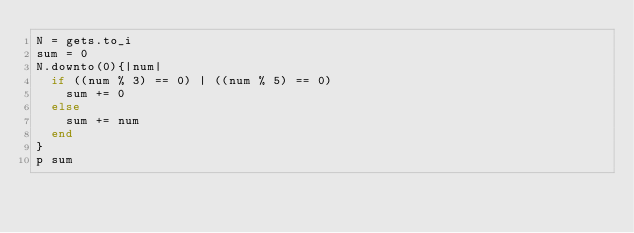Convert code to text. <code><loc_0><loc_0><loc_500><loc_500><_Ruby_>N = gets.to_i
sum = 0
N.downto(0){|num|
  if ((num % 3) == 0) | ((num % 5) == 0)
    sum += 0
  else
  	sum += num
  end
}
p sum
</code> 